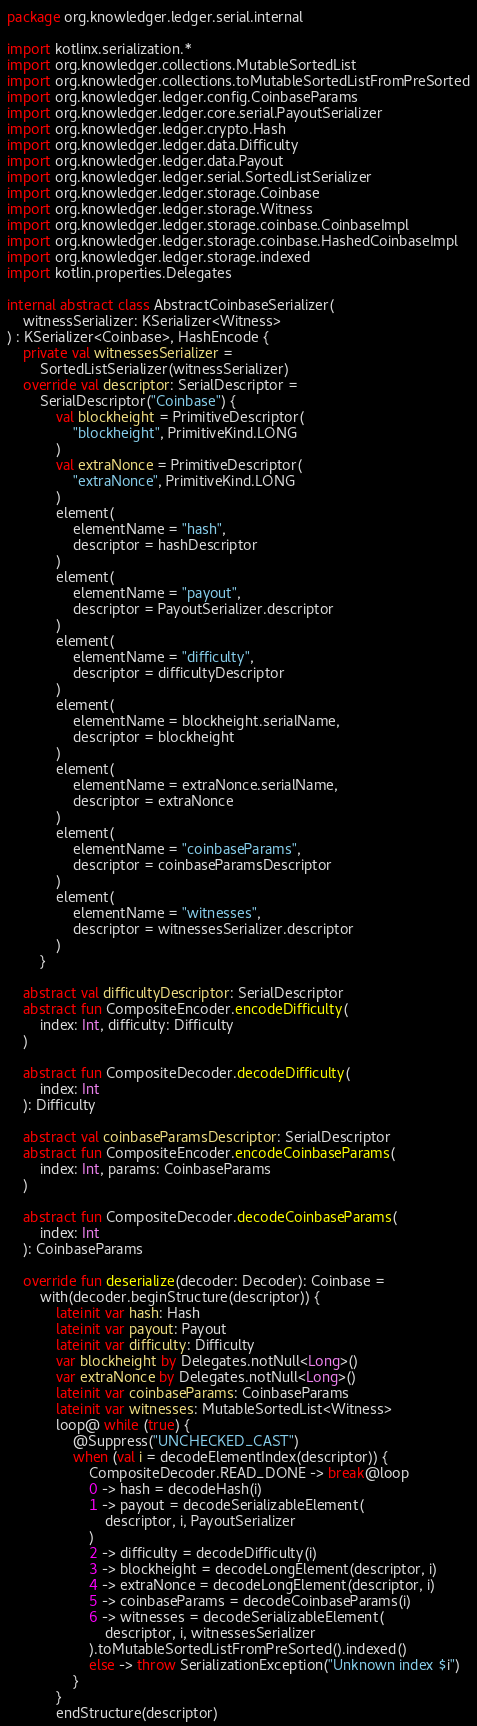<code> <loc_0><loc_0><loc_500><loc_500><_Kotlin_>package org.knowledger.ledger.serial.internal

import kotlinx.serialization.*
import org.knowledger.collections.MutableSortedList
import org.knowledger.collections.toMutableSortedListFromPreSorted
import org.knowledger.ledger.config.CoinbaseParams
import org.knowledger.ledger.core.serial.PayoutSerializer
import org.knowledger.ledger.crypto.Hash
import org.knowledger.ledger.data.Difficulty
import org.knowledger.ledger.data.Payout
import org.knowledger.ledger.serial.SortedListSerializer
import org.knowledger.ledger.storage.Coinbase
import org.knowledger.ledger.storage.Witness
import org.knowledger.ledger.storage.coinbase.CoinbaseImpl
import org.knowledger.ledger.storage.coinbase.HashedCoinbaseImpl
import org.knowledger.ledger.storage.indexed
import kotlin.properties.Delegates

internal abstract class AbstractCoinbaseSerializer(
    witnessSerializer: KSerializer<Witness>
) : KSerializer<Coinbase>, HashEncode {
    private val witnessesSerializer =
        SortedListSerializer(witnessSerializer)
    override val descriptor: SerialDescriptor =
        SerialDescriptor("Coinbase") {
            val blockheight = PrimitiveDescriptor(
                "blockheight", PrimitiveKind.LONG
            )
            val extraNonce = PrimitiveDescriptor(
                "extraNonce", PrimitiveKind.LONG
            )
            element(
                elementName = "hash",
                descriptor = hashDescriptor
            )
            element(
                elementName = "payout",
                descriptor = PayoutSerializer.descriptor
            )
            element(
                elementName = "difficulty",
                descriptor = difficultyDescriptor
            )
            element(
                elementName = blockheight.serialName,
                descriptor = blockheight
            )
            element(
                elementName = extraNonce.serialName,
                descriptor = extraNonce
            )
            element(
                elementName = "coinbaseParams",
                descriptor = coinbaseParamsDescriptor
            )
            element(
                elementName = "witnesses",
                descriptor = witnessesSerializer.descriptor
            )
        }

    abstract val difficultyDescriptor: SerialDescriptor
    abstract fun CompositeEncoder.encodeDifficulty(
        index: Int, difficulty: Difficulty
    )

    abstract fun CompositeDecoder.decodeDifficulty(
        index: Int
    ): Difficulty

    abstract val coinbaseParamsDescriptor: SerialDescriptor
    abstract fun CompositeEncoder.encodeCoinbaseParams(
        index: Int, params: CoinbaseParams
    )

    abstract fun CompositeDecoder.decodeCoinbaseParams(
        index: Int
    ): CoinbaseParams

    override fun deserialize(decoder: Decoder): Coinbase =
        with(decoder.beginStructure(descriptor)) {
            lateinit var hash: Hash
            lateinit var payout: Payout
            lateinit var difficulty: Difficulty
            var blockheight by Delegates.notNull<Long>()
            var extraNonce by Delegates.notNull<Long>()
            lateinit var coinbaseParams: CoinbaseParams
            lateinit var witnesses: MutableSortedList<Witness>
            loop@ while (true) {
                @Suppress("UNCHECKED_CAST")
                when (val i = decodeElementIndex(descriptor)) {
                    CompositeDecoder.READ_DONE -> break@loop
                    0 -> hash = decodeHash(i)
                    1 -> payout = decodeSerializableElement(
                        descriptor, i, PayoutSerializer
                    )
                    2 -> difficulty = decodeDifficulty(i)
                    3 -> blockheight = decodeLongElement(descriptor, i)
                    4 -> extraNonce = decodeLongElement(descriptor, i)
                    5 -> coinbaseParams = decodeCoinbaseParams(i)
                    6 -> witnesses = decodeSerializableElement(
                        descriptor, i, witnessesSerializer
                    ).toMutableSortedListFromPreSorted().indexed()
                    else -> throw SerializationException("Unknown index $i")
                }
            }
            endStructure(descriptor)</code> 